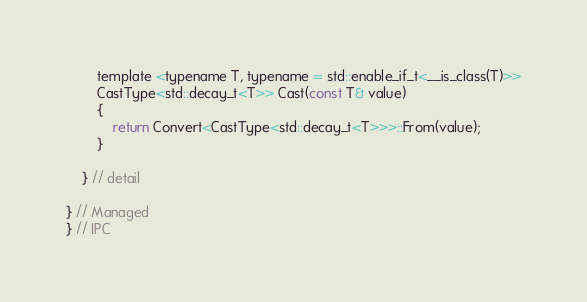<code> <loc_0><loc_0><loc_500><loc_500><_C_>
        template <typename T, typename = std::enable_if_t<__is_class(T)>>
        CastType<std::decay_t<T>> Cast(const T& value)
        {
            return Convert<CastType<std::decay_t<T>>>::From(value);
        }

    } // detail

} // Managed
} // IPC
</code> 